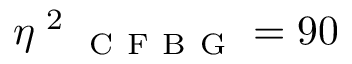Convert formula to latex. <formula><loc_0><loc_0><loc_500><loc_500>\eta \text  superscript { 2 } _ { C F B G } = 9 0 \</formula> 